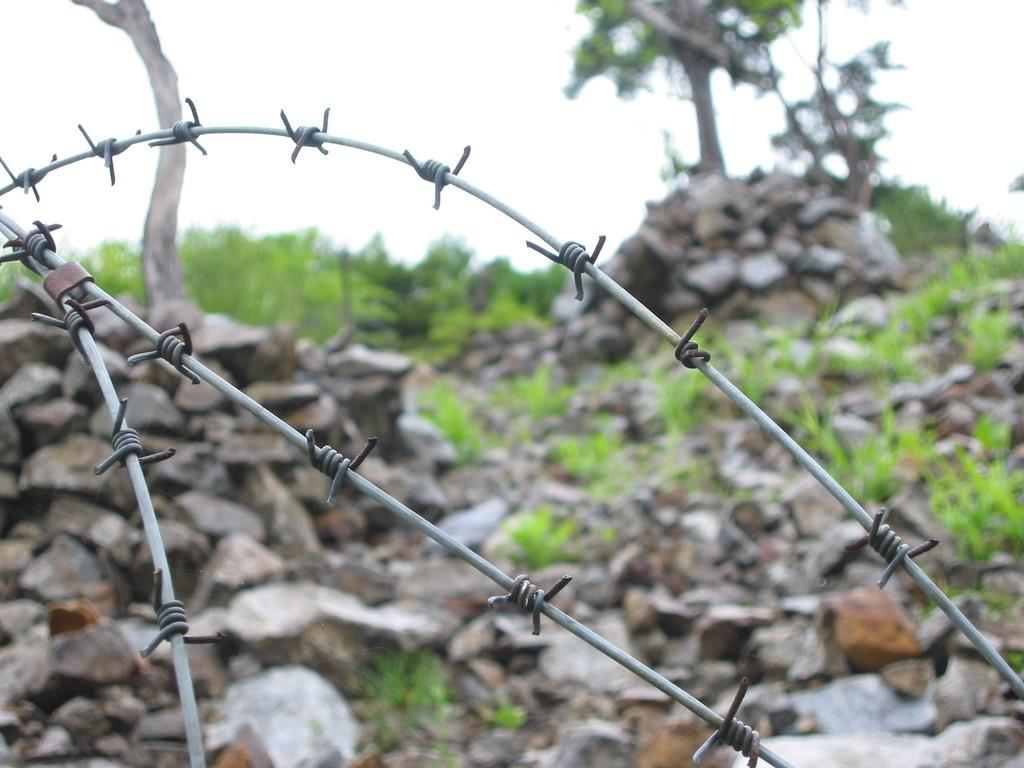What type of structure is present in the image? There is a fencing in the image. What can be seen at the bottom of the image? Many rocks are visible at the bottom of the image. What is in the background of the image? There is a tree and grass in the background of the image. What is visible at the top of the image? The sky is visible at the top of the image. How many plastic trucks are parked near the tree in the image? There are no plastic trucks present in the image. Is there a man standing next to the fencing in the image? There is no man visible in the image. 